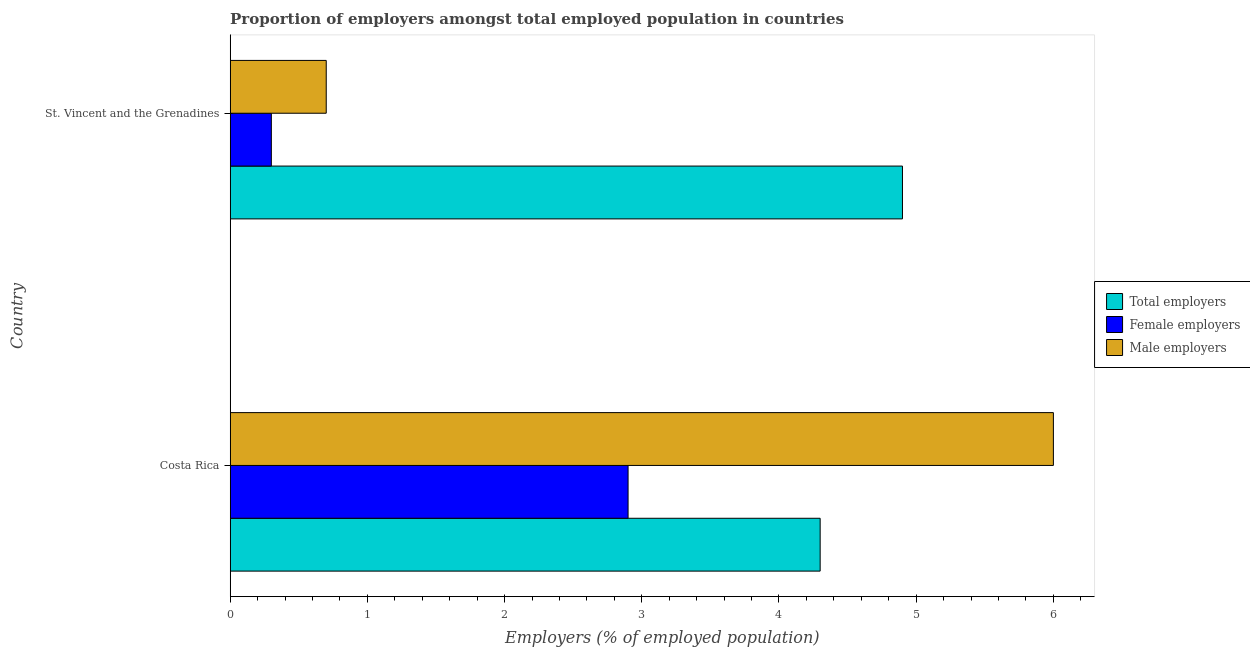How many different coloured bars are there?
Make the answer very short. 3. How many groups of bars are there?
Make the answer very short. 2. Are the number of bars on each tick of the Y-axis equal?
Your answer should be very brief. Yes. How many bars are there on the 1st tick from the top?
Provide a short and direct response. 3. How many bars are there on the 2nd tick from the bottom?
Keep it short and to the point. 3. What is the label of the 1st group of bars from the top?
Provide a short and direct response. St. Vincent and the Grenadines. What is the percentage of total employers in Costa Rica?
Your response must be concise. 4.3. Across all countries, what is the maximum percentage of female employers?
Your response must be concise. 2.9. Across all countries, what is the minimum percentage of total employers?
Give a very brief answer. 4.3. In which country was the percentage of total employers maximum?
Give a very brief answer. St. Vincent and the Grenadines. In which country was the percentage of female employers minimum?
Your response must be concise. St. Vincent and the Grenadines. What is the total percentage of female employers in the graph?
Provide a succinct answer. 3.2. What is the difference between the percentage of male employers in Costa Rica and the percentage of total employers in St. Vincent and the Grenadines?
Offer a very short reply. 1.1. What is the difference between the percentage of total employers and percentage of male employers in St. Vincent and the Grenadines?
Provide a short and direct response. 4.2. In how many countries, is the percentage of total employers greater than 4.2 %?
Your answer should be compact. 2. What is the ratio of the percentage of total employers in Costa Rica to that in St. Vincent and the Grenadines?
Your answer should be compact. 0.88. Is the percentage of total employers in Costa Rica less than that in St. Vincent and the Grenadines?
Your response must be concise. Yes. Is the difference between the percentage of male employers in Costa Rica and St. Vincent and the Grenadines greater than the difference between the percentage of total employers in Costa Rica and St. Vincent and the Grenadines?
Make the answer very short. Yes. What does the 2nd bar from the top in St. Vincent and the Grenadines represents?
Offer a terse response. Female employers. What does the 2nd bar from the bottom in Costa Rica represents?
Keep it short and to the point. Female employers. Is it the case that in every country, the sum of the percentage of total employers and percentage of female employers is greater than the percentage of male employers?
Ensure brevity in your answer.  Yes. Are all the bars in the graph horizontal?
Make the answer very short. Yes. How many countries are there in the graph?
Keep it short and to the point. 2. What is the difference between two consecutive major ticks on the X-axis?
Give a very brief answer. 1. Does the graph contain grids?
Your response must be concise. No. How are the legend labels stacked?
Your response must be concise. Vertical. What is the title of the graph?
Keep it short and to the point. Proportion of employers amongst total employed population in countries. What is the label or title of the X-axis?
Offer a terse response. Employers (% of employed population). What is the label or title of the Y-axis?
Your answer should be very brief. Country. What is the Employers (% of employed population) in Total employers in Costa Rica?
Keep it short and to the point. 4.3. What is the Employers (% of employed population) of Female employers in Costa Rica?
Your answer should be very brief. 2.9. What is the Employers (% of employed population) of Total employers in St. Vincent and the Grenadines?
Your answer should be very brief. 4.9. What is the Employers (% of employed population) of Female employers in St. Vincent and the Grenadines?
Make the answer very short. 0.3. What is the Employers (% of employed population) in Male employers in St. Vincent and the Grenadines?
Your response must be concise. 0.7. Across all countries, what is the maximum Employers (% of employed population) in Total employers?
Make the answer very short. 4.9. Across all countries, what is the maximum Employers (% of employed population) in Female employers?
Make the answer very short. 2.9. Across all countries, what is the minimum Employers (% of employed population) in Total employers?
Keep it short and to the point. 4.3. Across all countries, what is the minimum Employers (% of employed population) of Female employers?
Ensure brevity in your answer.  0.3. Across all countries, what is the minimum Employers (% of employed population) in Male employers?
Offer a terse response. 0.7. What is the total Employers (% of employed population) of Female employers in the graph?
Provide a short and direct response. 3.2. What is the difference between the Employers (% of employed population) of Total employers in Costa Rica and that in St. Vincent and the Grenadines?
Your answer should be very brief. -0.6. What is the difference between the Employers (% of employed population) in Female employers in Costa Rica and that in St. Vincent and the Grenadines?
Offer a very short reply. 2.6. What is the difference between the Employers (% of employed population) in Male employers in Costa Rica and that in St. Vincent and the Grenadines?
Offer a very short reply. 5.3. What is the difference between the Employers (% of employed population) in Total employers in Costa Rica and the Employers (% of employed population) in Male employers in St. Vincent and the Grenadines?
Offer a terse response. 3.6. What is the difference between the Employers (% of employed population) in Female employers in Costa Rica and the Employers (% of employed population) in Male employers in St. Vincent and the Grenadines?
Your answer should be compact. 2.2. What is the average Employers (% of employed population) of Female employers per country?
Keep it short and to the point. 1.6. What is the average Employers (% of employed population) in Male employers per country?
Your answer should be compact. 3.35. What is the difference between the Employers (% of employed population) of Total employers and Employers (% of employed population) of Female employers in Costa Rica?
Make the answer very short. 1.4. What is the difference between the Employers (% of employed population) of Total employers and Employers (% of employed population) of Female employers in St. Vincent and the Grenadines?
Provide a succinct answer. 4.6. What is the ratio of the Employers (% of employed population) of Total employers in Costa Rica to that in St. Vincent and the Grenadines?
Keep it short and to the point. 0.88. What is the ratio of the Employers (% of employed population) in Female employers in Costa Rica to that in St. Vincent and the Grenadines?
Give a very brief answer. 9.67. What is the ratio of the Employers (% of employed population) of Male employers in Costa Rica to that in St. Vincent and the Grenadines?
Offer a very short reply. 8.57. What is the difference between the highest and the second highest Employers (% of employed population) of Female employers?
Give a very brief answer. 2.6. What is the difference between the highest and the second highest Employers (% of employed population) in Male employers?
Make the answer very short. 5.3. What is the difference between the highest and the lowest Employers (% of employed population) of Total employers?
Your response must be concise. 0.6. What is the difference between the highest and the lowest Employers (% of employed population) of Female employers?
Your response must be concise. 2.6. 